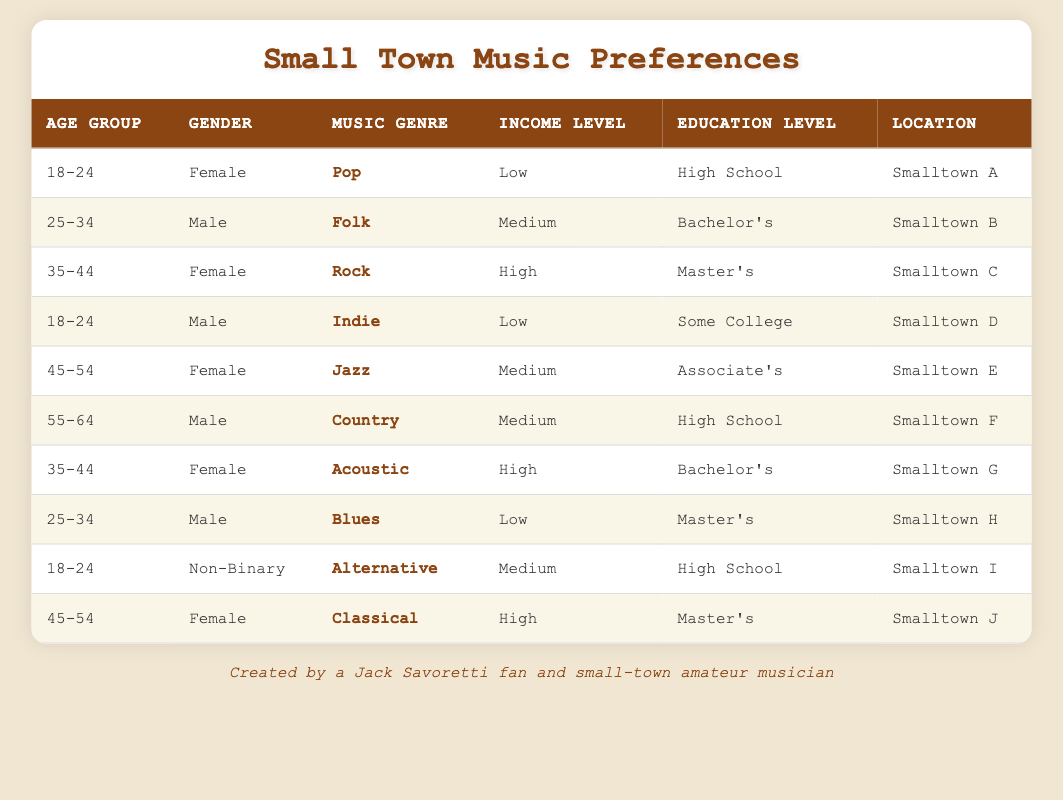What music genre is most preferred by females aged 35-44? From the table, there are two females in the age group 35-44. One prefers Rock (Smalltown C) and the other prefers Acoustic (Smalltown G). Both genres are tied for preference in this demographic.
Answer: Rock and Acoustic How many individuals prefer Pop music? There is one individual listed as preferring Pop music in the table (a female from Smalltown A).
Answer: 1 Is there a male in the table who prefers Indie music? Yes, there is a male who prefers Indie music, identified in the age group 18-24 from Smalltown D.
Answer: Yes What is the most common income level among those who prefer Country music? A male aged 55-64 from Smalltown F prefers Country music and is listed as having a medium income level. As there are no other entries for Country, we conclude that the most common income level is medium.
Answer: Medium How many different music genres are preferred by individuals aged 45-54 in the table? There are two individuals in this age group, both females from Smalltown E and Smalltown J, preferring Jazz and Classical respectively. Thus, there are two different music genres preferred by individuals aged 45-54.
Answer: 2 What education level do the individuals who prefer Jazz and Classical both have? The female preferring Jazz has an Associate's degree, while the female preferring Classical has a Master's degree. Therefore, they do not share the same education level.
Answer: No Which gender has the highest representation in the table? Examining the table reveals that there are five females, four males, and one non-binary individual, thus females have the highest representation.
Answer: Female What is the average age group of individuals who prefer Folk and Blues? The male who prefers Folk is in the 25-34 age group, and the male who prefers Blues is also in the same age group. Thus, the average age group is 25-34.
Answer: 25-34 Does any individual in the table have a low income level and prefer Alternative music? The non-binary individual in Smalltown I prefers Alternative music and has a medium income level, therefore there is no one with a low income level preferring Alternative.
Answer: No 